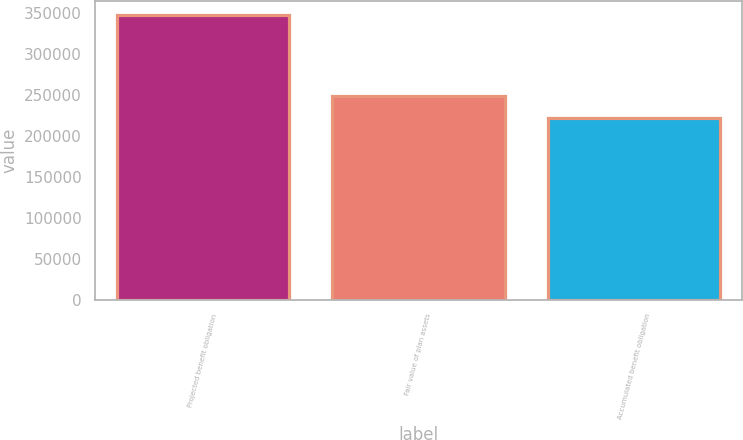<chart> <loc_0><loc_0><loc_500><loc_500><bar_chart><fcel>Projected benefit obligation<fcel>Fair value of plan assets<fcel>Accumulated benefit obligation<nl><fcel>347665<fcel>249329<fcel>221715<nl></chart> 